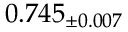Convert formula to latex. <formula><loc_0><loc_0><loc_500><loc_500>0 . 7 4 5 _ { \pm 0 . 0 0 7 }</formula> 